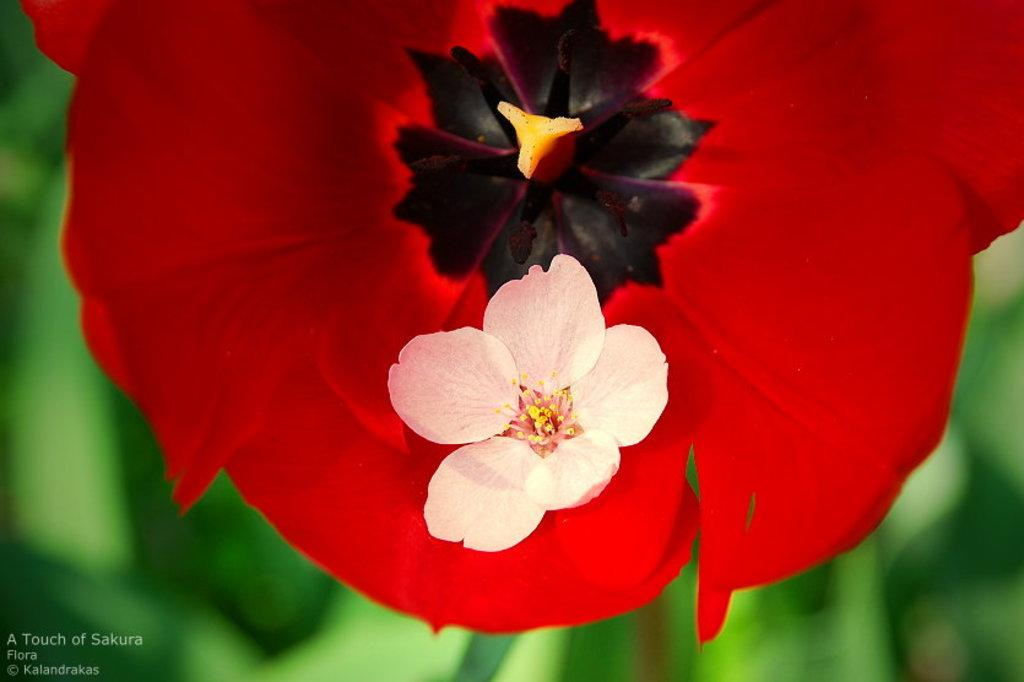What type of flower is the main subject of the image? There is a red color flower in the image. Are there any other flowers present in the image? Yes, there is another flower on the red flower. How would you describe the background of the image? The background of the image is blurry. Can you find any text in the image? Yes, there is some text in the left bottom of the image. What type of curtain is hanging in the background of the image? There is no curtain present in the image; the background is blurry. What offer is being made by the flower in the image? The image does not depict any offers being made by the flower; it is a still image of a flower. 